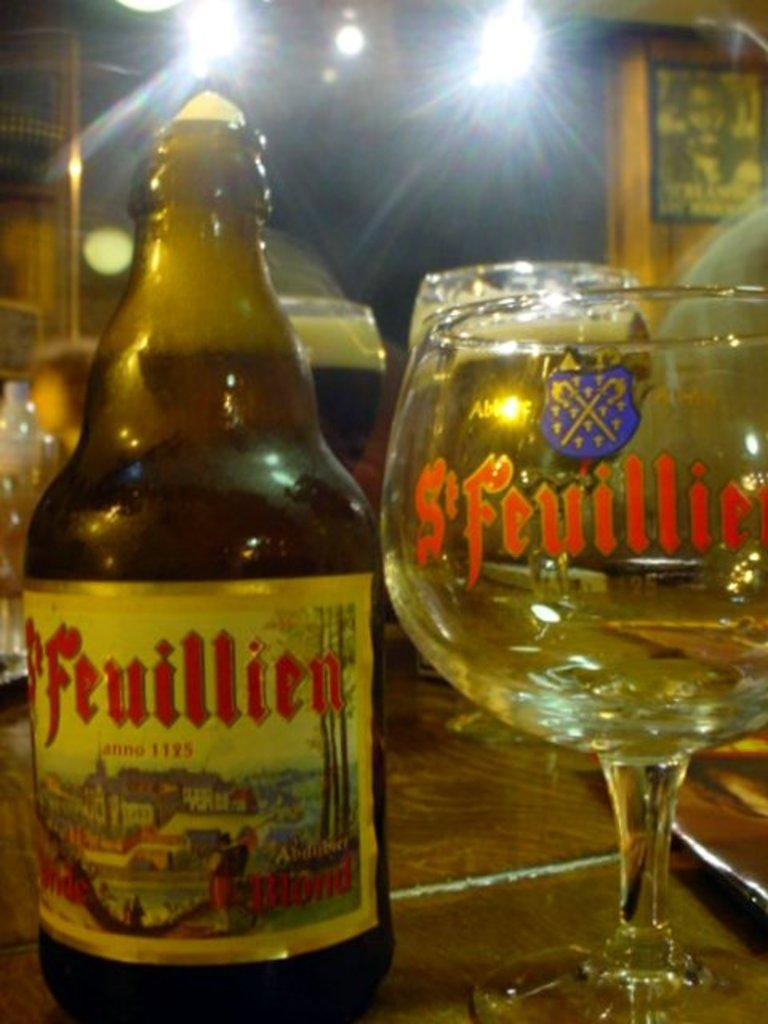What is one object visible in the image? There is a bottle in the image. What else can be seen in the image? There are glasses in the image. Can you describe another element in the image? There is a light in the image. Where is the kettle located in the image? There is no kettle present in the image. What type of lift is visible in the image? There is no lift present in the image. 